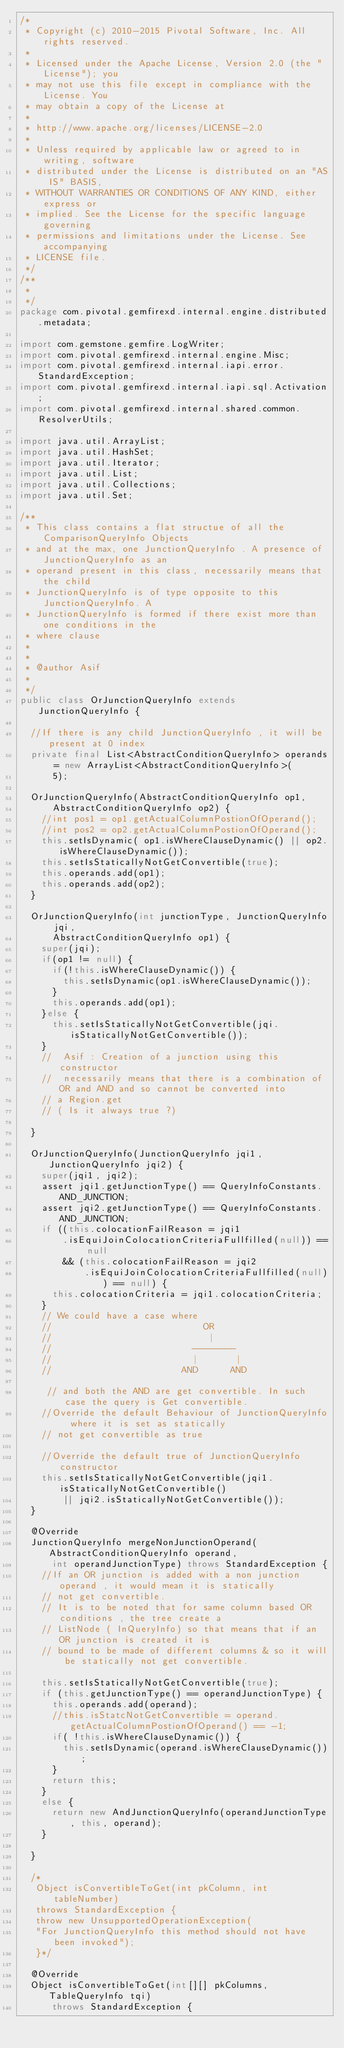<code> <loc_0><loc_0><loc_500><loc_500><_Java_>/*
 * Copyright (c) 2010-2015 Pivotal Software, Inc. All rights reserved.
 *
 * Licensed under the Apache License, Version 2.0 (the "License"); you
 * may not use this file except in compliance with the License. You
 * may obtain a copy of the License at
 *
 * http://www.apache.org/licenses/LICENSE-2.0
 *
 * Unless required by applicable law or agreed to in writing, software
 * distributed under the License is distributed on an "AS IS" BASIS,
 * WITHOUT WARRANTIES OR CONDITIONS OF ANY KIND, either express or
 * implied. See the License for the specific language governing
 * permissions and limitations under the License. See accompanying
 * LICENSE file.
 */
/**
 * 
 */
package com.pivotal.gemfirexd.internal.engine.distributed.metadata;

import com.gemstone.gemfire.LogWriter;
import com.pivotal.gemfirexd.internal.engine.Misc;
import com.pivotal.gemfirexd.internal.iapi.error.StandardException;
import com.pivotal.gemfirexd.internal.iapi.sql.Activation;
import com.pivotal.gemfirexd.internal.shared.common.ResolverUtils;

import java.util.ArrayList;
import java.util.HashSet;
import java.util.Iterator;
import java.util.List;
import java.util.Collections;
import java.util.Set;

/**
 * This class contains a flat structue of all the ComparisonQueryInfo Objects
 * and at the max, one JunctionQueryInfo . A presence of JunctionQueryInfo as an
 * operand present in this class, necessarily means that the child
 * JunctionQueryInfo is of type opposite to this JunctionQueryInfo. A
 * JunctionQueryInfo is formed if there exist more than one conditions in the
 * where clause
 * 
 * 
 * @author Asif
 * 
 */
public class OrJunctionQueryInfo extends JunctionQueryInfo {

  //If there is any child JunctionQueryInfo , it will be present at 0 index
  private final List<AbstractConditionQueryInfo> operands = new ArrayList<AbstractConditionQueryInfo>(
      5);

  OrJunctionQueryInfo(AbstractConditionQueryInfo op1,
      AbstractConditionQueryInfo op2) {
    //int pos1 = op1.getActualColumnPostionOfOperand();
    //int pos2 = op2.getActualColumnPostionOfOperand();
    this.setIsDynamic( op1.isWhereClauseDynamic() || op2.isWhereClauseDynamic());
    this.setIsStaticallyNotGetConvertible(true);
    this.operands.add(op1);
    this.operands.add(op2);
  }

  OrJunctionQueryInfo(int junctionType, JunctionQueryInfo jqi,
      AbstractConditionQueryInfo op1) {
    super(jqi);
    if(op1 != null) {
      if(!this.isWhereClauseDynamic()) {
        this.setIsDynamic(op1.isWhereClauseDynamic());
      }    
      this.operands.add(op1);
    }else {
      this.setIsStaticallyNotGetConvertible(jqi.isStaticallyNotGetConvertible());
    }
    //  Asif : Creation of a junction using this constructor 
    //  necessarily means that there is a combination of OR and AND and so cannot be converted into
    // a Region.get
    // ( Is it always true ?)    

  }

  OrJunctionQueryInfo(JunctionQueryInfo jqi1, JunctionQueryInfo jqi2) {
    super(jqi1, jqi2);
    assert jqi1.getJunctionType() == QueryInfoConstants.AND_JUNCTION;
    assert jqi2.getJunctionType() == QueryInfoConstants.AND_JUNCTION;
    if ((this.colocationFailReason = jqi1
        .isEquiJoinColocationCriteriaFullfilled(null)) == null
        && (this.colocationFailReason = jqi2
            .isEquiJoinColocationCriteriaFullfilled(null)) == null) {
      this.colocationCriteria = jqi1.colocationCriteria;
    }
    // We could have a case where 
    //                            OR
    //                             |
    //                          --------
    //                          |       |
    //                        AND      AND
                            
     // and both the AND are get convertible. In such case the query is Get convertible.
    //Override the default Behaviour of JunctionQueryInfo  where it is set as statically 
    // not get convertible as true

    //Override the default true of JunctionQueryInfo constructor
    this.setIsStaticallyNotGetConvertible(jqi1.isStaticallyNotGetConvertible()
        || jqi2.isStaticallyNotGetConvertible());
  }

  @Override
  JunctionQueryInfo mergeNonJunctionOperand(AbstractConditionQueryInfo operand,
      int operandJunctionType) throws StandardException {
    //If an OR junction is added with a non junction operand , it would mean it is statically
    // not get convertible.
    // It is to be noted that for same column based OR conditions , the tree create a
    // ListNode ( InQueryInfo) so that means that if an OR junction is created it is
    // bound to be made of different columns & so it will be statically not get convertible.
                               
    this.setIsStaticallyNotGetConvertible(true);
    if (this.getJunctionType() == operandJunctionType) {
      this.operands.add(operand);
      //this.isStatcNotGetConvertible = operand.getActualColumnPostionOfOperand() == -1;
      if( !this.isWhereClauseDynamic()) {
        this.setIsDynamic(operand.isWhereClauseDynamic());  
      }     
      return this;
    }
    else {
      return new AndJunctionQueryInfo(operandJunctionType, this, operand);
    }

  }

  /*
   Object isConvertibleToGet(int pkColumn, int tableNumber)
   throws StandardException {
   throw new UnsupportedOperationException(
   "For JunctionQueryInfo this method should not have been invoked");
   }*/

  @Override
  Object isConvertibleToGet(int[][] pkColumns, TableQueryInfo tqi)
      throws StandardException {</code> 